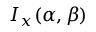Convert formula to latex. <formula><loc_0><loc_0><loc_500><loc_500>I _ { x } ( \alpha , \beta )</formula> 